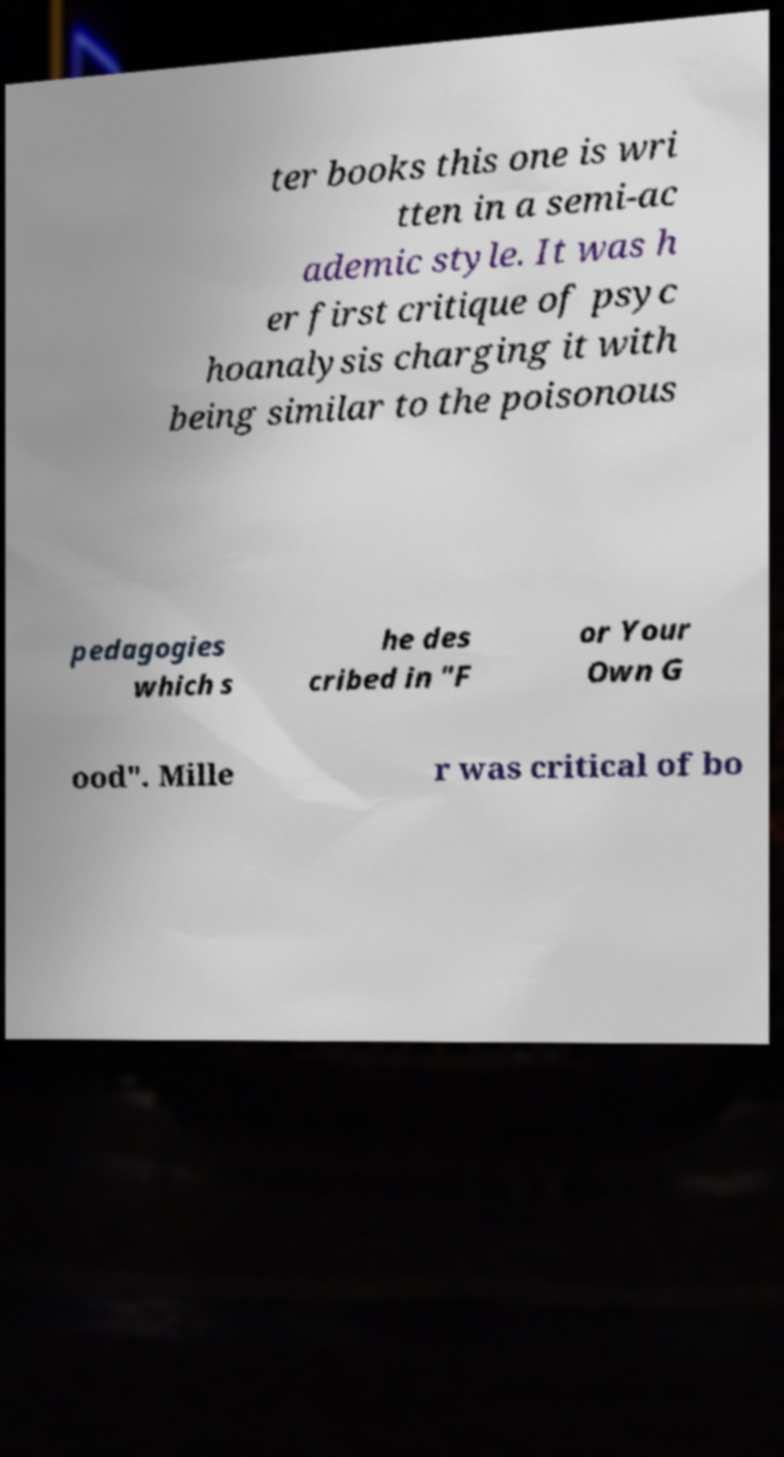Could you extract and type out the text from this image? ter books this one is wri tten in a semi-ac ademic style. It was h er first critique of psyc hoanalysis charging it with being similar to the poisonous pedagogies which s he des cribed in "F or Your Own G ood". Mille r was critical of bo 